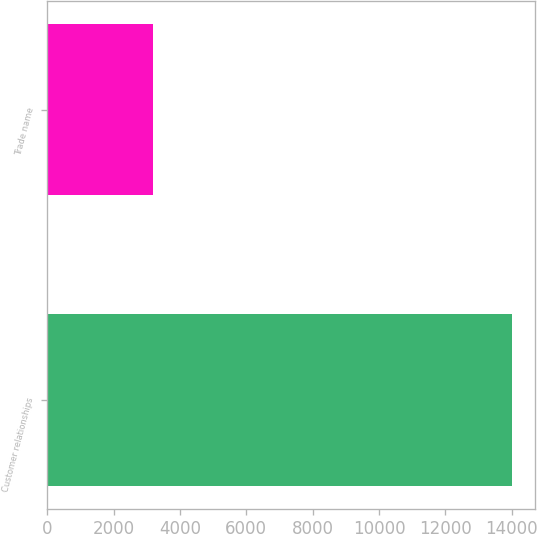Convert chart to OTSL. <chart><loc_0><loc_0><loc_500><loc_500><bar_chart><fcel>Customer relationships<fcel>Trade name<nl><fcel>13997<fcel>3194<nl></chart> 